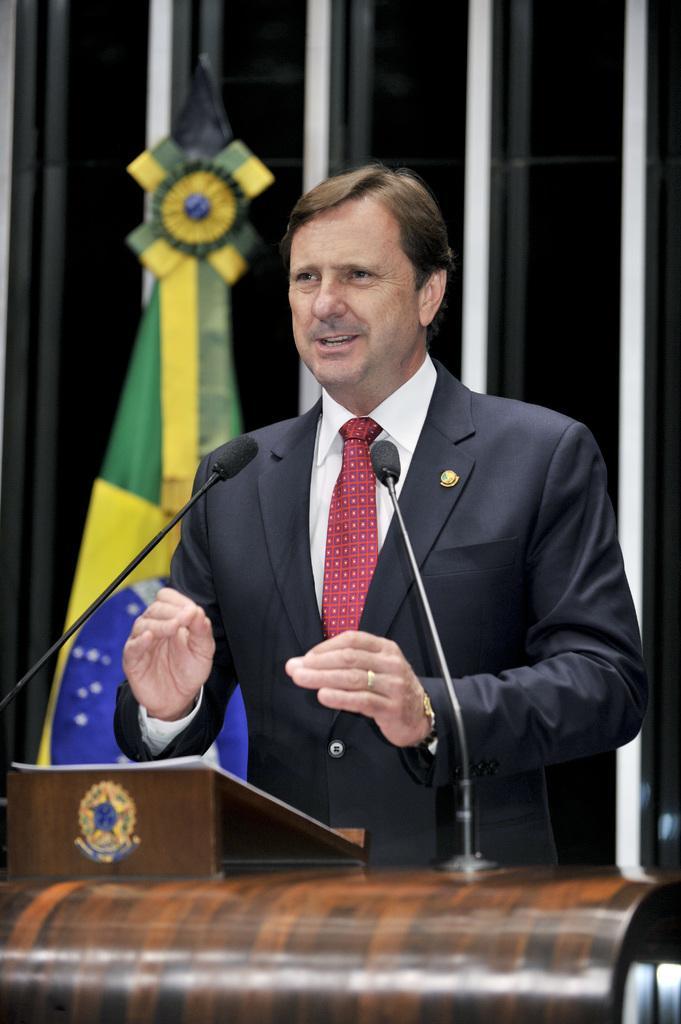Please provide a concise description of this image. In the foreground of this image, there is a man wearing a suit is standing in front of a podium on which there are mice and a book holder. In the background, it seems like a flag and few white objects. 